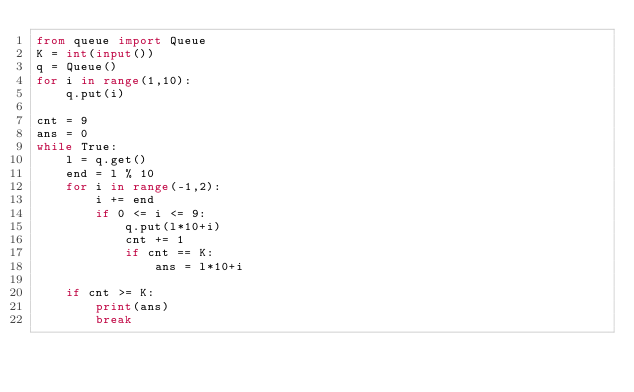Convert code to text. <code><loc_0><loc_0><loc_500><loc_500><_Python_>from queue import Queue
K = int(input())
q = Queue()
for i in range(1,10):
    q.put(i)

cnt = 9
ans = 0
while True:
    l = q.get()
    end = l % 10
    for i in range(-1,2):
        i += end
        if 0 <= i <= 9:
            q.put(l*10+i)
            cnt += 1
            if cnt == K:
                ans = l*10+i

    if cnt >= K:
        print(ans)
        break
</code> 